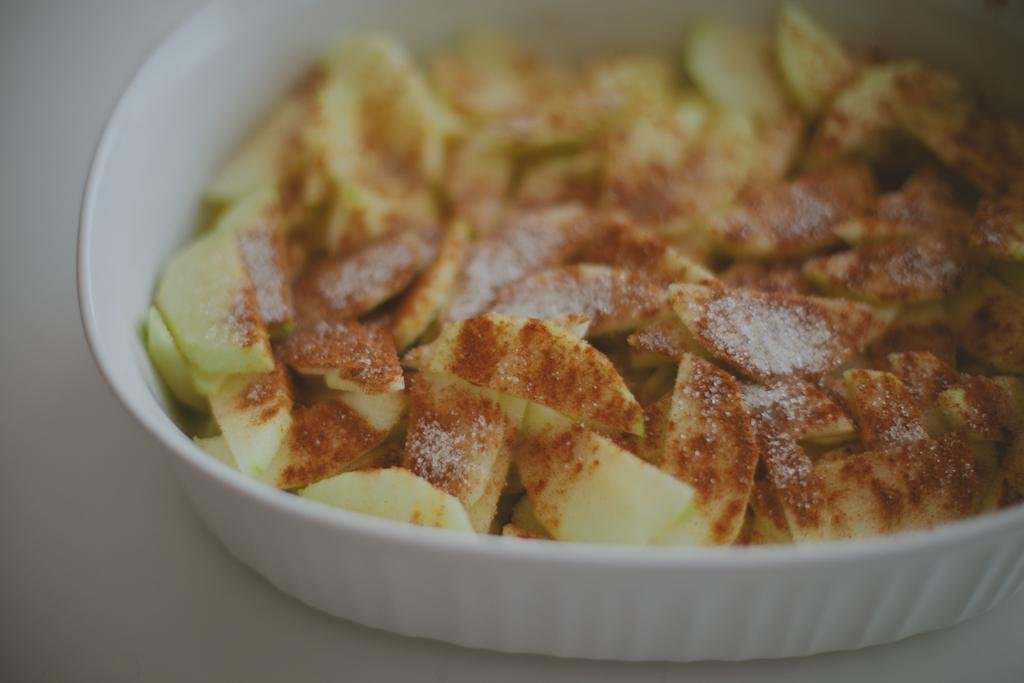What type of food can be seen in the image? There is food in the image, but the specific type cannot be determined from the facts provided. What color is the plate that holds the food? The plate is white. On what surface is the white plate placed? The white plate is placed on a white surface. What position does the committee hold in the current political climate? There is no mention of a committee or political climate in the image or the provided facts, so this question cannot be answered. 